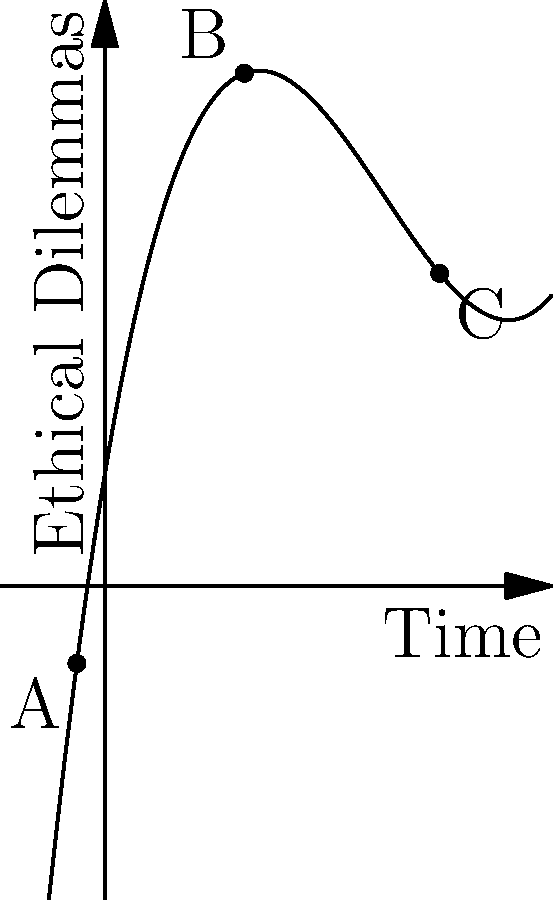The graph represents the relationship between technological advancements (x-axis) and ethical dilemmas (y-axis) throughout history. Points A, B, and C mark significant historical periods. Which point likely represents the Industrial Revolution, and why? To determine which point represents the Industrial Revolution, let's analyze each point:

1. Point A: Located at the beginning of the curve, it represents a period with relatively low technological advancement and few ethical dilemmas. This likely corresponds to pre-industrial times.

2. Point B: Positioned at a local maximum on the curve, it indicates a period of significant increase in ethical dilemmas relative to technological advancements. This aligns with the Industrial Revolution, as it brought about rapid technological change and numerous new ethical challenges.

3. Point C: Found at the rightmost part of the curve, it shows the highest level of technological advancement but a moderate level of ethical dilemmas. This likely represents the modern or post-industrial era.

The Industrial Revolution is characterized by:
a) Rapid technological advancements
b) Significant social and economic changes
c) The emergence of new ethical issues related to labor, urbanization, and environmental impact

Point B best fits these criteria, as it shows a substantial increase in ethical dilemmas corresponding to technological progress, which is typical of the Industrial Revolution period.
Answer: Point B 